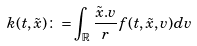<formula> <loc_0><loc_0><loc_500><loc_500>k ( t , \tilde { x } ) \colon = \int _ { \mathbb { R ^ { 3 } } } \frac { \tilde { x } . v } { r } f ( t , \tilde { x } , v ) d v</formula> 